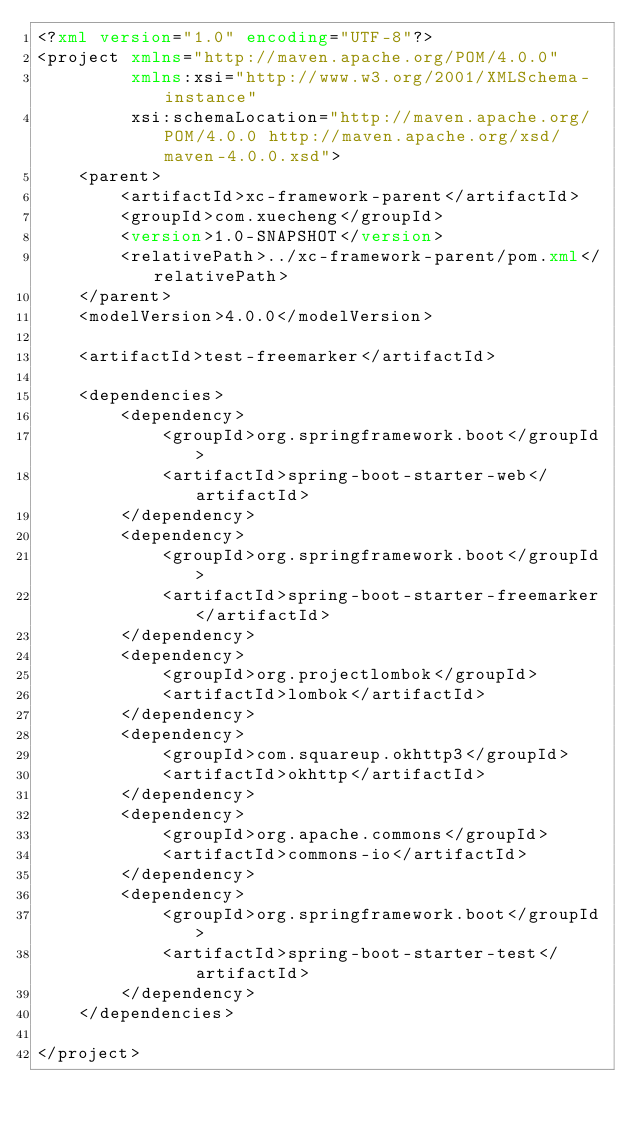<code> <loc_0><loc_0><loc_500><loc_500><_XML_><?xml version="1.0" encoding="UTF-8"?>
<project xmlns="http://maven.apache.org/POM/4.0.0"
         xmlns:xsi="http://www.w3.org/2001/XMLSchema-instance"
         xsi:schemaLocation="http://maven.apache.org/POM/4.0.0 http://maven.apache.org/xsd/maven-4.0.0.xsd">
    <parent>
        <artifactId>xc-framework-parent</artifactId>
        <groupId>com.xuecheng</groupId>
        <version>1.0-SNAPSHOT</version>
        <relativePath>../xc-framework-parent/pom.xml</relativePath>
    </parent>
    <modelVersion>4.0.0</modelVersion>

    <artifactId>test-freemarker</artifactId>

    <dependencies>
        <dependency>
            <groupId>org.springframework.boot</groupId>
            <artifactId>spring-boot-starter-web</artifactId>
        </dependency>
        <dependency>
            <groupId>org.springframework.boot</groupId>
            <artifactId>spring-boot-starter-freemarker</artifactId>
        </dependency>
        <dependency>
            <groupId>org.projectlombok</groupId>
            <artifactId>lombok</artifactId>
        </dependency>
        <dependency>
            <groupId>com.squareup.okhttp3</groupId>
            <artifactId>okhttp</artifactId>
        </dependency>
        <dependency>
            <groupId>org.apache.commons</groupId>
            <artifactId>commons-io</artifactId>
        </dependency>
        <dependency>
            <groupId>org.springframework.boot</groupId>
            <artifactId>spring-boot-starter-test</artifactId>
        </dependency>
    </dependencies>

</project></code> 